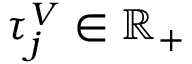Convert formula to latex. <formula><loc_0><loc_0><loc_500><loc_500>\tau _ { j } ^ { V } \in \mathbb { R } _ { + }</formula> 